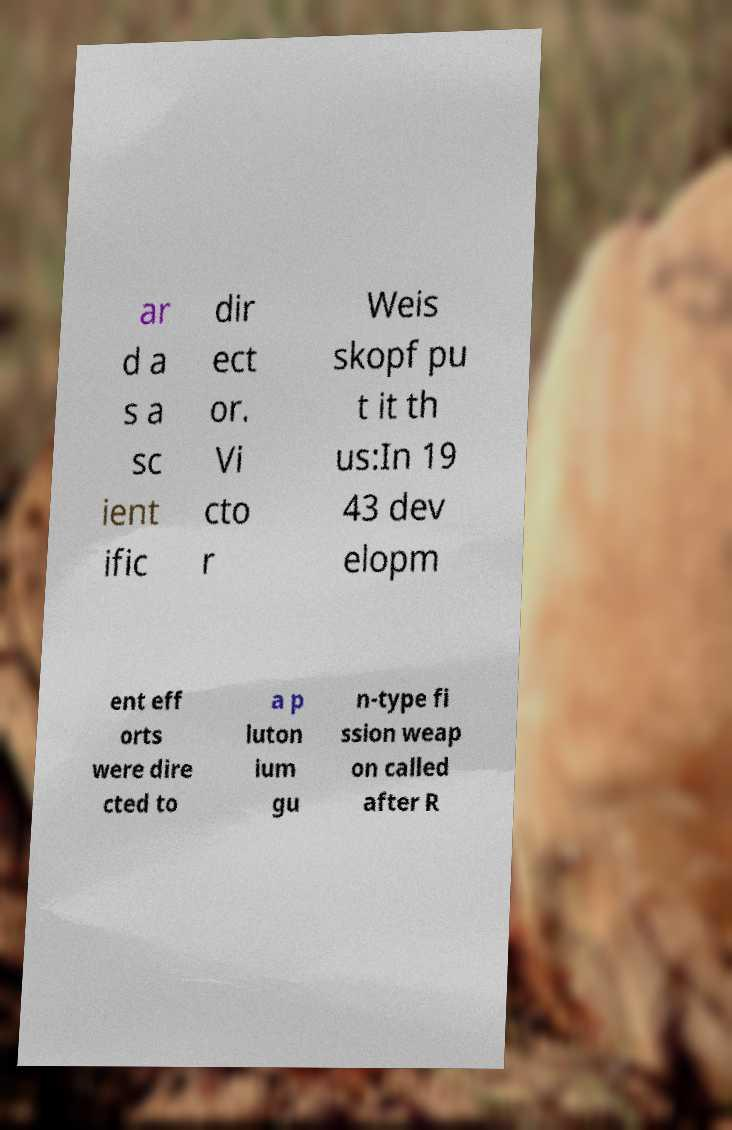I need the written content from this picture converted into text. Can you do that? ar d a s a sc ient ific dir ect or. Vi cto r Weis skopf pu t it th us:In 19 43 dev elopm ent eff orts were dire cted to a p luton ium gu n-type fi ssion weap on called after R 